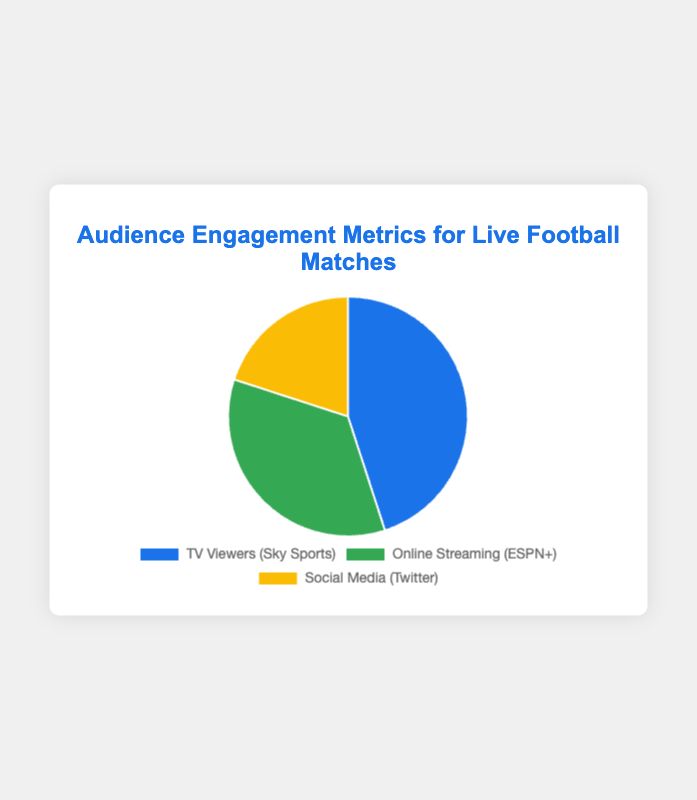Which Platform has the highest audience engagement? The platform with the highest audience engagement can be determined by looking at the data point with the largest percentage. TV Viewers via Sky Sports accounts for 45%, which is the highest.
Answer: TV Viewers (Sky Sports) What is the combined percentage of audience engagement for Online Streaming and Social Media? To find the combined percentage, sum the percentages for Online Streaming (35%) and Social Media (20%). So, 35% + 20% equals 55%.
Answer: 55% How much larger is the TV Viewers engagement than Social Media engagement? Subtract the Social Media engagement percentage from the TV Viewers engagement percentage. So, 45% - 20% equals 25%.
Answer: 25% Which platform has the least audience engagement? The platform with the least engagement is indicated by the smallest percentage. Social Media (Twitter) has 20%, which is the lowest engagement.
Answer: Social Media (Twitter) What is the average audience engagement percentage across all platforms? To calculate the average, sum all percentages and divide by the number of platforms: (45% + 35% + 20%) / 3 = 100% / 3 = 33.3%.
Answer: 33.3% What is the difference in audience engagement between TV Viewers and Online Streaming? Subtract the Online Streaming percentage from the TV Viewers percentage. So, 45% - 35% equals 10%.
Answer: 10% What percentage of the total engagement is not associated with TV Viewers? Subtract the TV Viewers percentage from 100%. So, 100% - 45% equals 55%.
Answer: 55% Which platform has a 35% engagement rate? Identify the platform corresponding to the 35% engagement rate from the data. Online Streaming via ESPN+ has a 35% engagement rate.
Answer: Online Streaming (ESPN+) Is the combined engagement of TV Viewers and Social Media greater than that of Online Streaming? Sum the percentages for TV Viewers and Social Media to compare with Online Streaming. TV Viewers (45%) + Social Media (20%) = 65%, which is greater than Online Streaming (35%).
Answer: Yes Between Online Streaming and Social Media, which platform has higher engagement, and by how much? Compare the engagement percentages of the two platforms. Online Streaming (35%) is higher than Social Media (20%), with a difference of 35% - 20% = 15%.
Answer: Online Streaming, 15% 